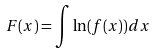Convert formula to latex. <formula><loc_0><loc_0><loc_500><loc_500>F ( x ) = \int \ln ( f ( x ) ) d x</formula> 